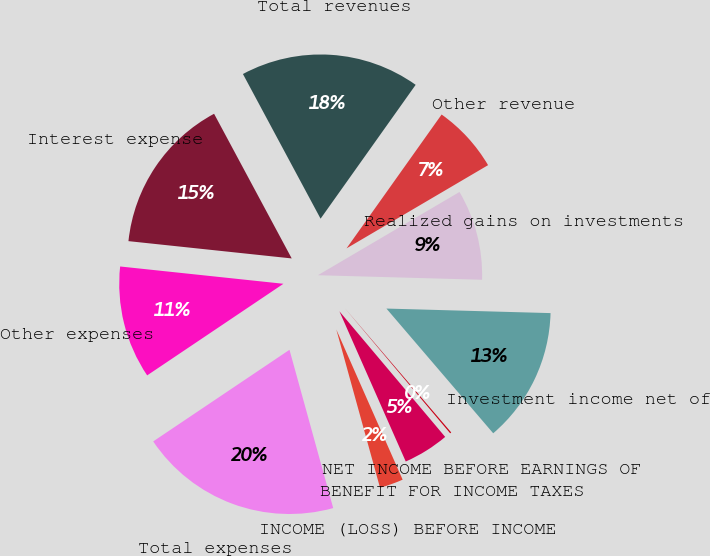Convert chart to OTSL. <chart><loc_0><loc_0><loc_500><loc_500><pie_chart><fcel>Investment income net of<fcel>Realized gains on investments<fcel>Other revenue<fcel>Total revenues<fcel>Interest expense<fcel>Other expenses<fcel>Total expenses<fcel>INCOME (LOSS) BEFORE INCOME<fcel>BENEFIT FOR INCOME TAXES<fcel>NET INCOME BEFORE EARNINGS OF<nl><fcel>13.29%<fcel>8.9%<fcel>6.71%<fcel>17.67%<fcel>15.48%<fcel>11.1%<fcel>19.87%<fcel>2.33%<fcel>4.52%<fcel>0.13%<nl></chart> 